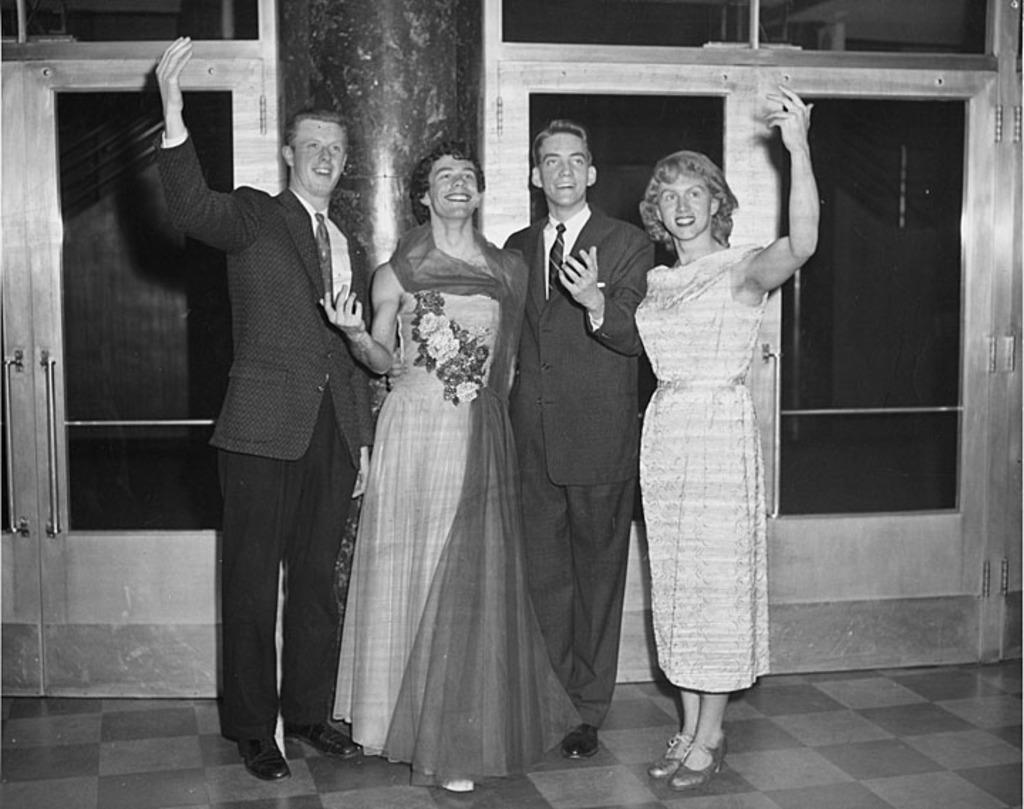What is the color scheme of the image? The image is black and white. How many people are the people are positioned in the image? There are four people standing in the middle of the image. What is the surface on which the people are standing? The people are standing on the floor. What can be seen in the background of the image? There is a closed door in the background of the image. What type of basket is being used for the discussion in the image? There is no basket or discussion present in the image. How many quilts are visible on the floor in the image? There are no quilts visible in the image; the people are standing on the floor. 